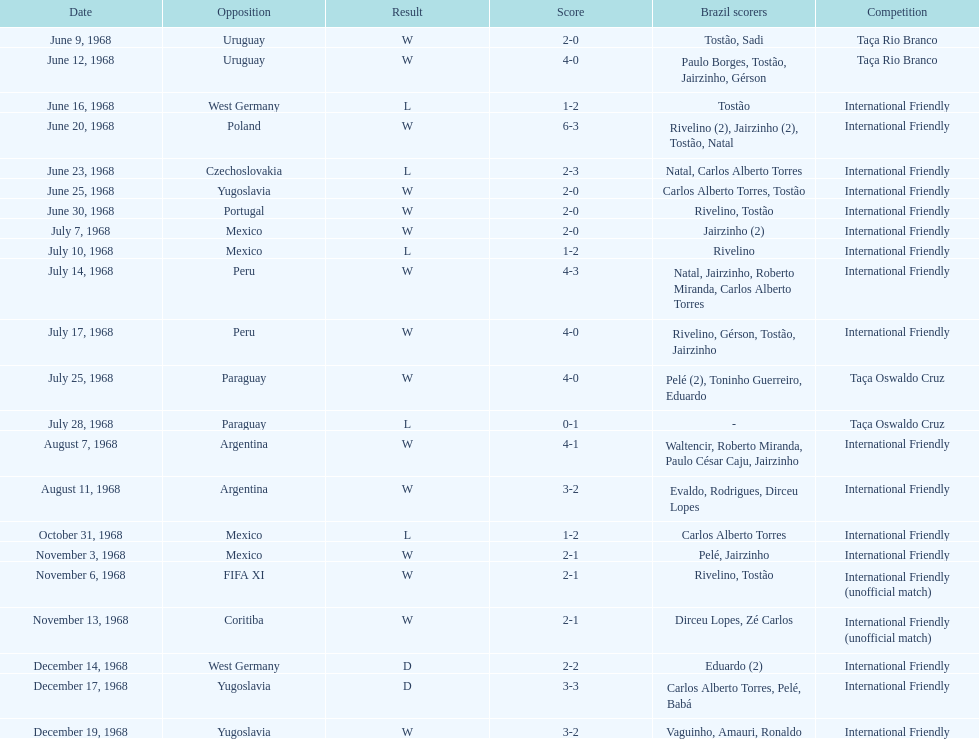What is the top score ever scored by the brazil national team? 6. 